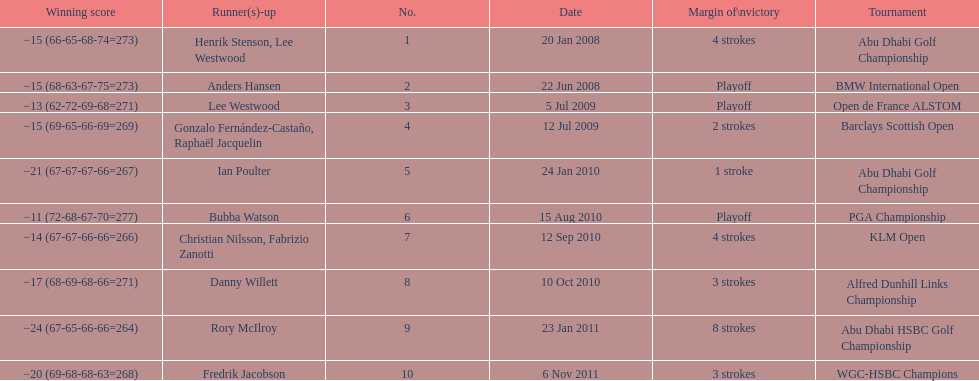How long separated the playoff victory at bmw international open and the 4 stroke victory at the klm open? 2 years. 